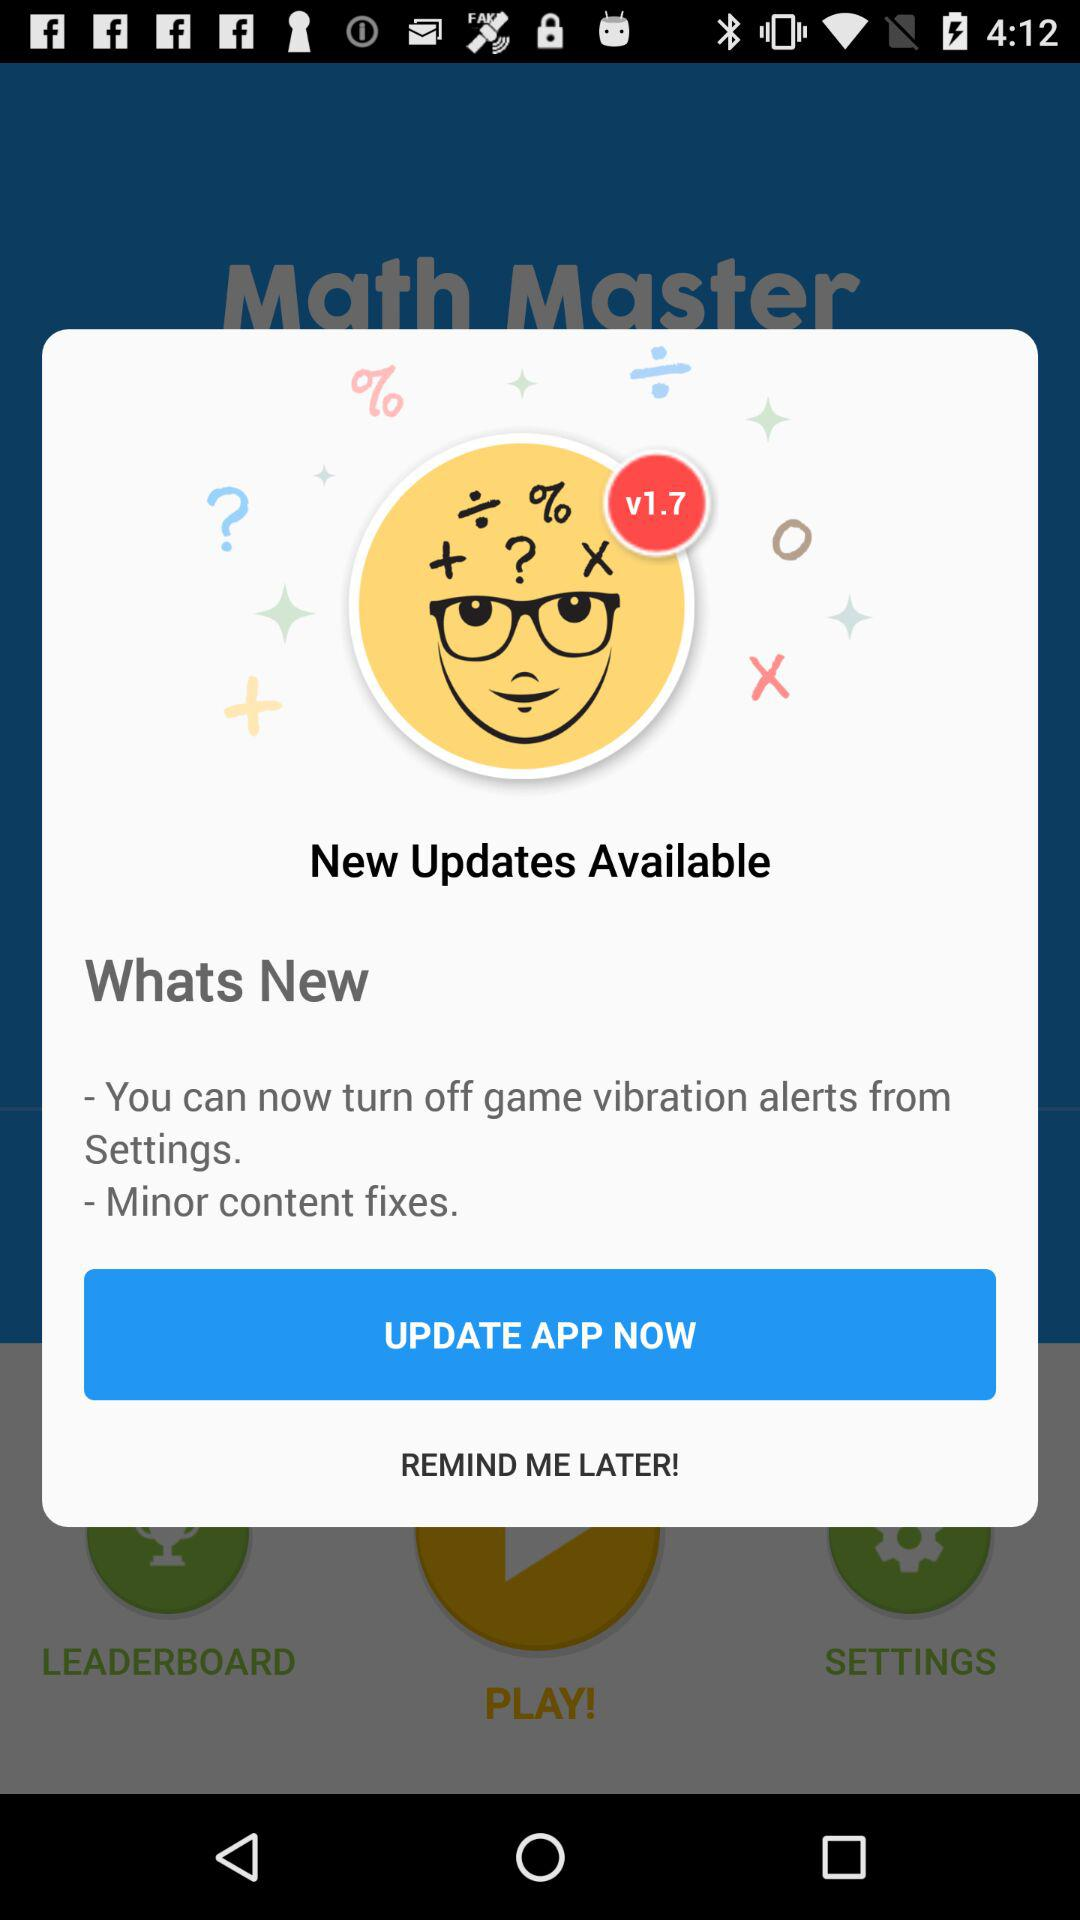Which version is available for updates? The version that is available for updates is v1.7. 